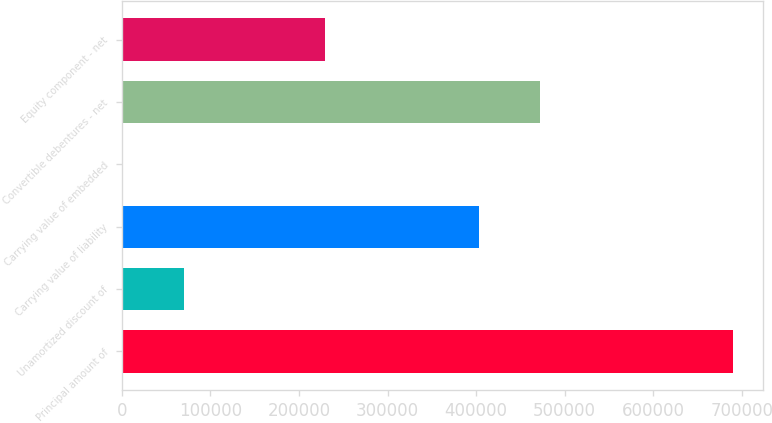Convert chart. <chart><loc_0><loc_0><loc_500><loc_500><bar_chart><fcel>Principal amount of<fcel>Unamortized discount of<fcel>Carrying value of liability<fcel>Carrying value of embedded<fcel>Convertible debentures - net<fcel>Equity component - net<nl><fcel>689635<fcel>69726.7<fcel>403002<fcel>848<fcel>471880<fcel>229513<nl></chart> 